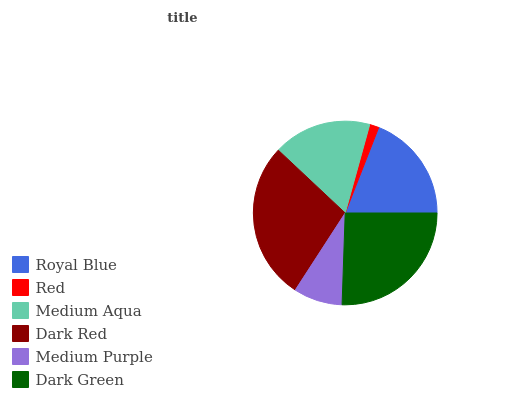Is Red the minimum?
Answer yes or no. Yes. Is Dark Red the maximum?
Answer yes or no. Yes. Is Medium Aqua the minimum?
Answer yes or no. No. Is Medium Aqua the maximum?
Answer yes or no. No. Is Medium Aqua greater than Red?
Answer yes or no. Yes. Is Red less than Medium Aqua?
Answer yes or no. Yes. Is Red greater than Medium Aqua?
Answer yes or no. No. Is Medium Aqua less than Red?
Answer yes or no. No. Is Royal Blue the high median?
Answer yes or no. Yes. Is Medium Aqua the low median?
Answer yes or no. Yes. Is Dark Green the high median?
Answer yes or no. No. Is Dark Green the low median?
Answer yes or no. No. 